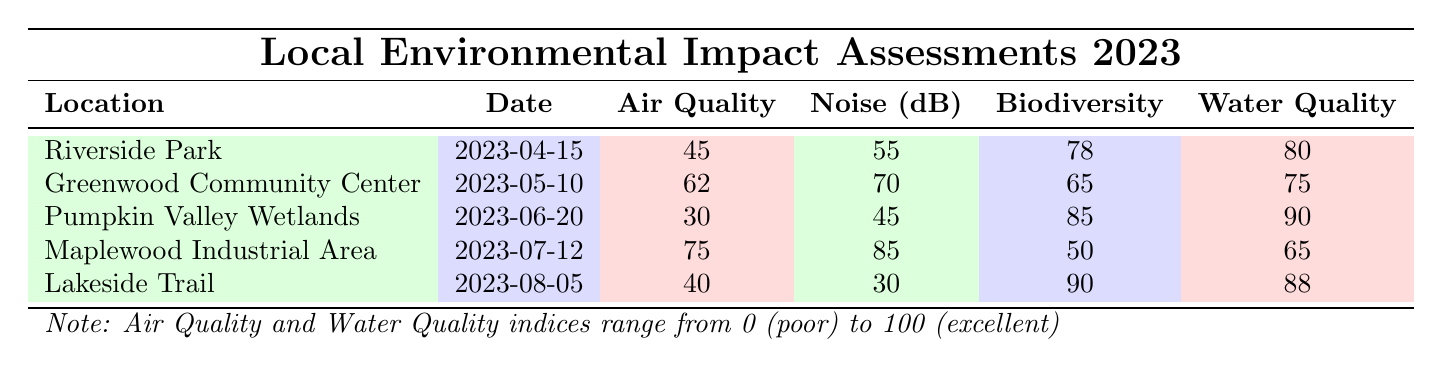What is the air quality index for Lakeside Trail? The air quality index for Lakeside Trail is directly listed in the table under the 'Air Quality' column for that location.
Answer: 40 Which location had the highest water quality index? To find the highest water quality index, I look at the 'Water Quality' column and identify the maximum value. The values are 80, 75, 90, 65, and 88. The highest is 90 at Pumpkin Valley Wetlands.
Answer: Pumpkin Valley Wetlands What is the difference in noise levels between Maplewood Industrial Area and Lakeside Trail? I first check the 'Noise (dB)' column for both locations. Maplewood Industrial Area has a noise level of 85 dB and Lakeside Trail has 30 dB. The difference is calculated as 85 - 30 = 55 dB.
Answer: 55 Is the biodiversity score for Greenwood Community Center higher than that for Riverside Park? I compare the biodiversity scores from the 'Biodiversity' column for both locations. The score for Greenwood Community Center is 65 and for Riverside Park, it is 78. Since 65 is less than 78, the statement is false.
Answer: No What is the average air quality index of all five locations? I find the air quality indices: 45, 62, 30, 75, and 40. I add these values (45 + 62 + 30 + 75 + 40) to get a total of 252. Then I divide by the number of locations, which is 5, to find the average: 252 / 5 = 50.4.
Answer: 50.4 What key finding describes the noise levels at Maplewood Industrial Area? The key finding for Maplewood Industrial Area, listed in the 'Key Findings' section, explains that there are high noise and air pollution levels, indicating potential health concerns for nearby residents.
Answer: High noise and air pollution levels; potential health concerns for nearby residents How many locations reported good biodiversity scores (above 70)? I look at the 'Biodiversity' column to count the scores above 70: Riverside Park (78), Pumpkin Valley Wetlands (85), and Lakeside Trail (90) are the only locations that meet this criterion. So, there are 3 locations with good biodiversity scores.
Answer: 3 Is it true that all assessments conducted in 2023 reported air quality indices above 30? Checking the 'Air Quality' column, I see the indices are 45, 62, 30, 75, and 40. The assessment for Pumpkin Valley Wetlands reported an air quality index of 30. Thus, not all assessments reported values above 30, making the statement false.
Answer: No What is the combined air quality index of Riverside Park and Lakeside Trail? I add the air quality indices for Riverside Park (45) and Lakeside Trail (40) together: 45 + 40 = 85.
Answer: 85 